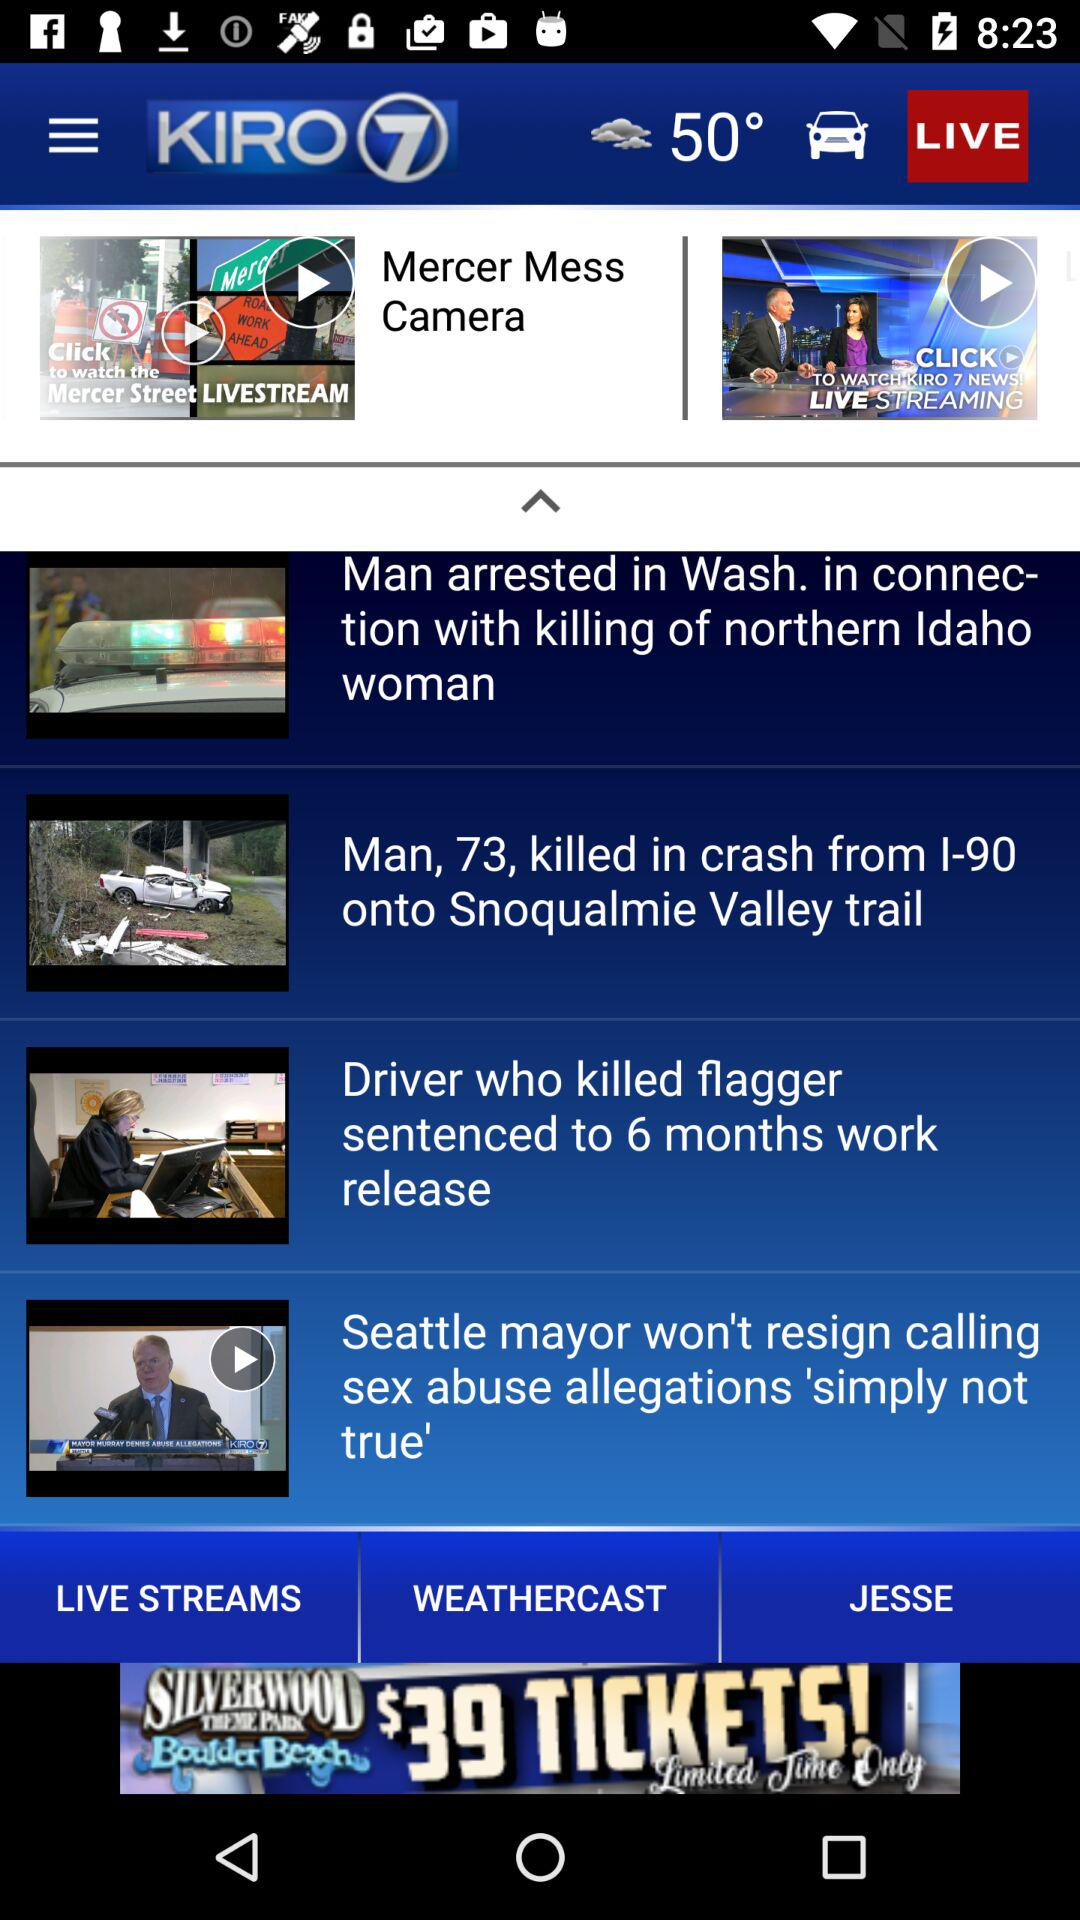What is the temperature? The temperature is 50°. 